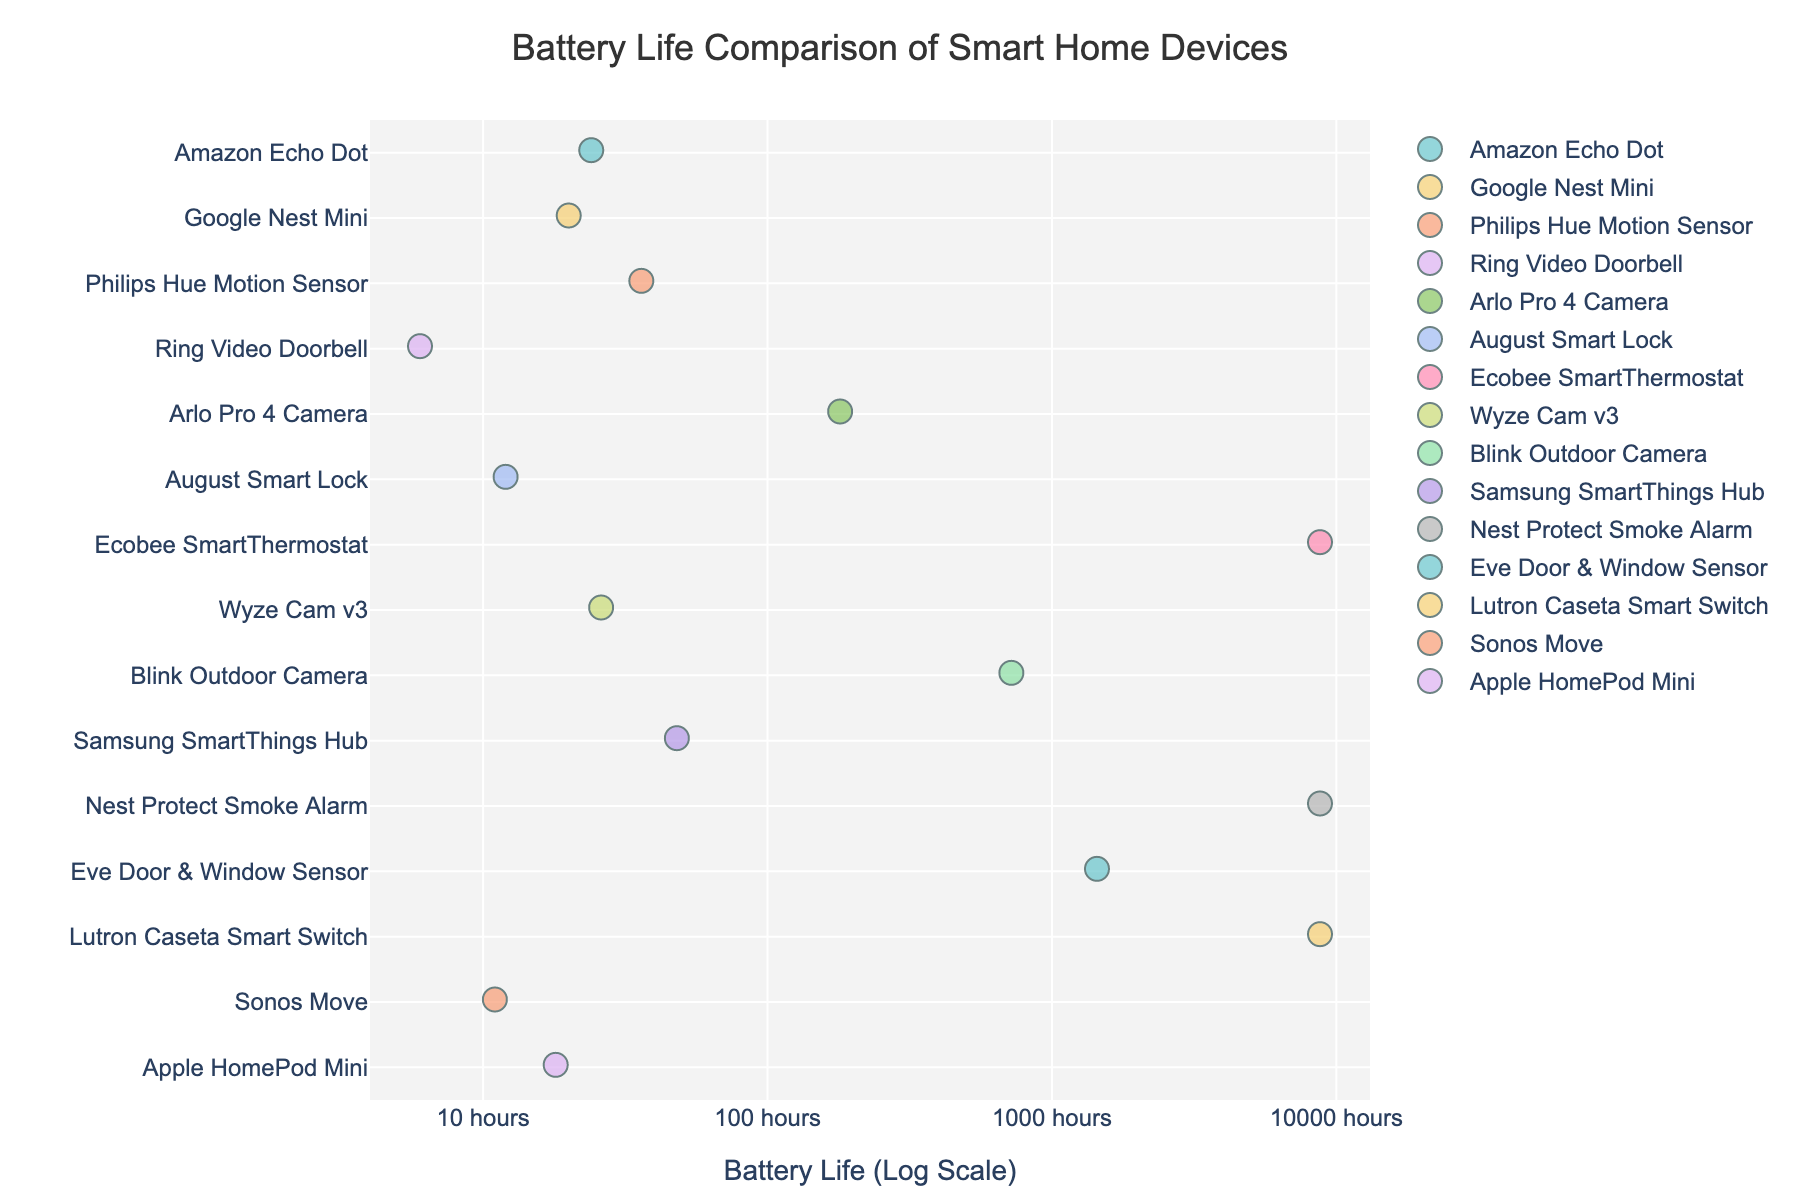What is the title of the plot? The title of the plot is usually found at the top center of the figure, giving a brief description of the visualized data. In this case, it helps the viewer understand that the plot shows a comparison of battery life across different smart home devices.
Answer: Battery Life Comparison of Smart Home Devices What does the x-axis represent? The x-axis typically holds the variable being measured or compared. Here, the x-axis represents the battery life of smart home devices, transformed into a logarithmic scale for better visualization of the data range.
Answer: Battery Life (Log Scale) Which smart home device has the longest battery life in terms of hours? To find the device with the longest battery life, look for the data point furthest to the right on the x-axis. In this case, it corresponds to a high number of battery hours.
Answer: Ecobee SmartThermostat How many devices have a battery life exceeding 1,000 hours? First, identify where '1,000 hours' is located on the x-axis. Then, count the number of data points to the right of this marker that represent devices with a battery life exceeding 1,000 hours.
Answer: 4 What is the battery life of the Ring Video Doorbell? Hover over the point representing the Ring Video Doorbell to read its battery life. The hover data reveals the exact number of hours.
Answer: 6 hours Which device has a shorter battery life, the Apple HomePod Mini or the Amazon Echo Dot? Compare the positions of the data points for these two devices on the x-axis. The one further to the left has a shorter battery life.
Answer: Apple HomePod Mini How does the Wyze Cam v3 compare to the Blink Outdoor Camera in terms of battery life? Compare the positions of the dots for the Wyze Cam v3 and the Blink Outdoor Camera on the x-axis. The one further to the right has a longer battery life.
Answer: Blink Outdoor Camera has a longer battery life What's the range of battery life values observed in the plot? Determine the minimum and maximum values on the x-axis where data points are present. The range is the difference between these values.
Answer: 6 hours to 8,760 hours Which devices have a battery life under 20 hours? Identify the position on the x-axis where '20 hours' is located and find data points to the left of this marker. These represent devices with a battery life under 20 hours.
Answer: Google Nest Mini, Sonos Move, August Smart Lock, Ring Video Doorbell, Apple HomePod Mini, Amazon Echo Dot 